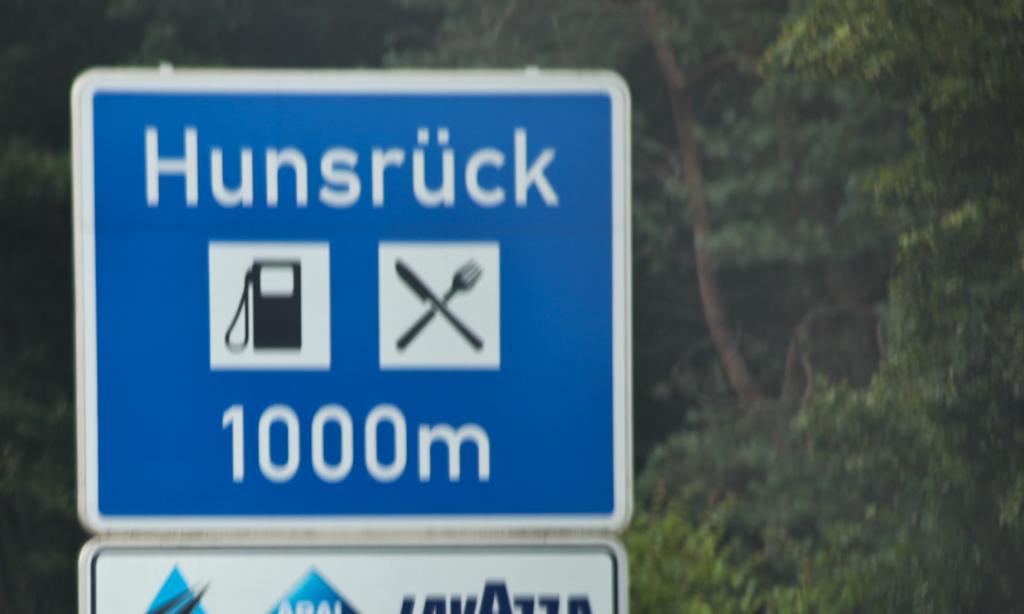How many meters is displayed on the sign?
Ensure brevity in your answer.  1000. Where is this?
Your answer should be compact. Hunsruck. 